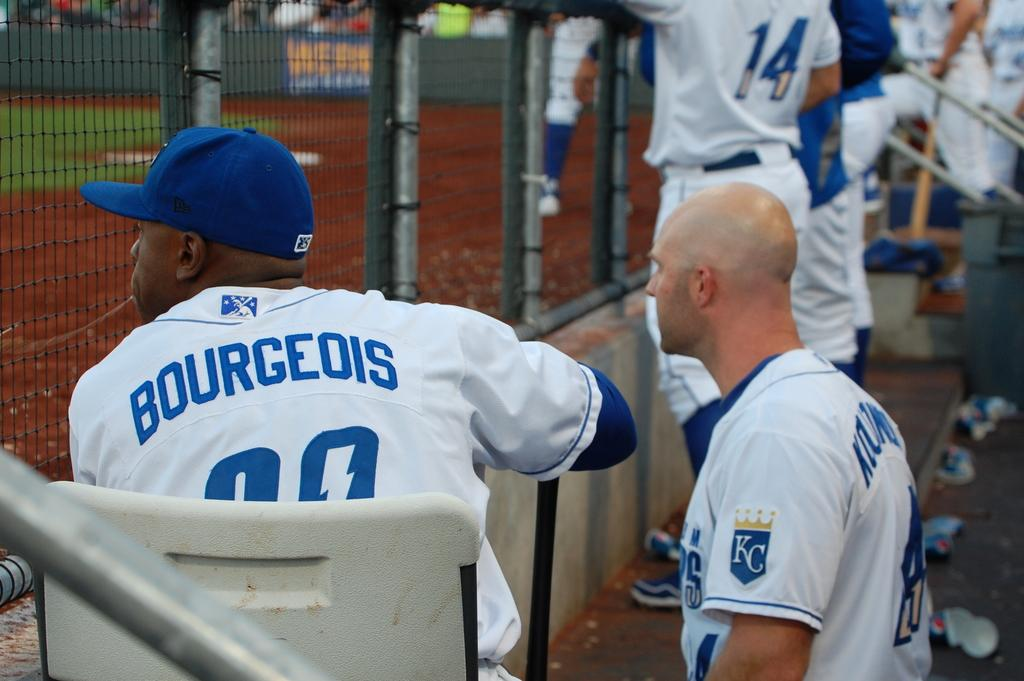<image>
Offer a succinct explanation of the picture presented. Players are seen sitting in the KC dugout. 